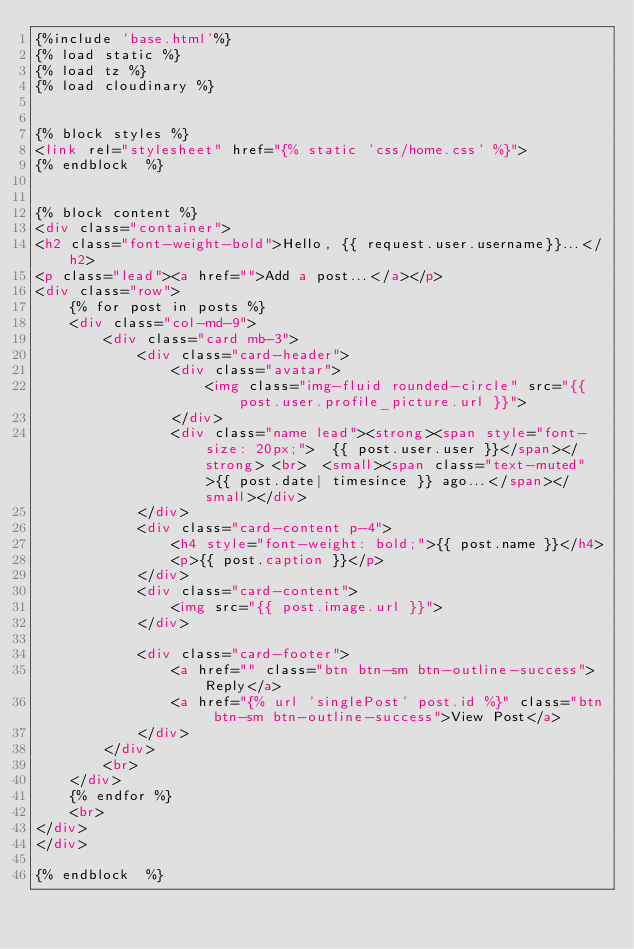Convert code to text. <code><loc_0><loc_0><loc_500><loc_500><_HTML_>{%include 'base.html'%}
{% load static %}
{% load tz %}
{% load cloudinary %}


{% block styles %}
<link rel="stylesheet" href="{% static 'css/home.css' %}">  
{% endblock  %}
  

{% block content %} 
<div class="container">
<h2 class="font-weight-bold">Hello, {{ request.user.username}}...</h2>
<p class="lead"><a href="">Add a post...</a></p>
<div class="row">
    {% for post in posts %}
    <div class="col-md-9">
        <div class="card mb-3">
            <div class="card-header">
                <div class="avatar">
                    <img class="img-fluid rounded-circle" src="{{ post.user.profile_picture.url }}">
                </div>
                <div class="name lead"><strong><span style="font-size: 20px;">  {{ post.user.user }}</span></strong> <br>  <small><span class="text-muted">{{ post.date| timesince }} ago...</span></small></div>
            </div>
            <div class="card-content p-4">
                <h4 style="font-weight: bold;">{{ post.name }}</h4>
                <p>{{ post.caption }}</p>
            </div>
            <div class="card-content">
                <img src="{{ post.image.url }}">
            </div>
            
            <div class="card-footer">
                <a href="" class="btn btn-sm btn-outline-success">Reply</a>
                <a href="{% url 'singlePost' post.id %}" class="btn btn-sm btn-outline-success">View Post</a>
            </div>
        </div>
        <br>
    </div>
    {% endfor %}
    <br>
</div>
</div>

{% endblock  %}</code> 